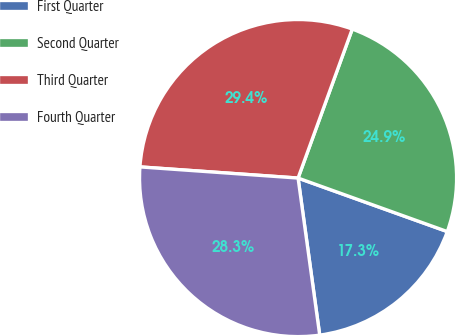<chart> <loc_0><loc_0><loc_500><loc_500><pie_chart><fcel>First Quarter<fcel>Second Quarter<fcel>Third Quarter<fcel>Fourth Quarter<nl><fcel>17.34%<fcel>24.93%<fcel>29.43%<fcel>28.3%<nl></chart> 